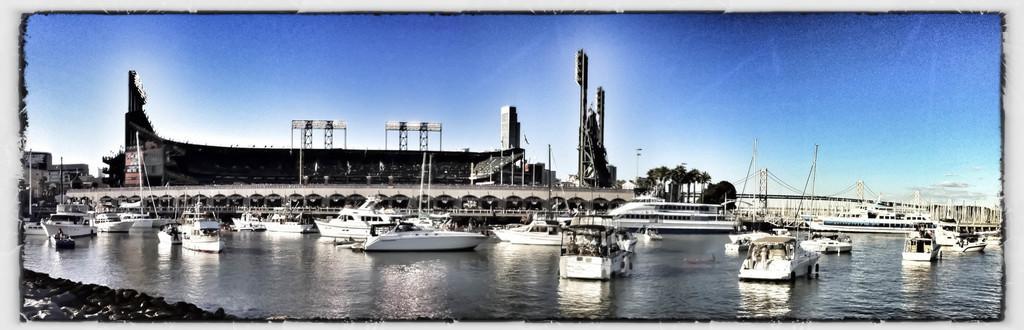Describe this image in one or two sentences. In this image I can see water in the front and on it I can see number of boats. In the background I can see few buildings, few trees, a bridge and the sky. 